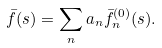Convert formula to latex. <formula><loc_0><loc_0><loc_500><loc_500>\bar { f } ( s ) = \sum _ { n } a _ { n } \bar { f } _ { n } ^ { ( 0 ) } ( s ) .</formula> 